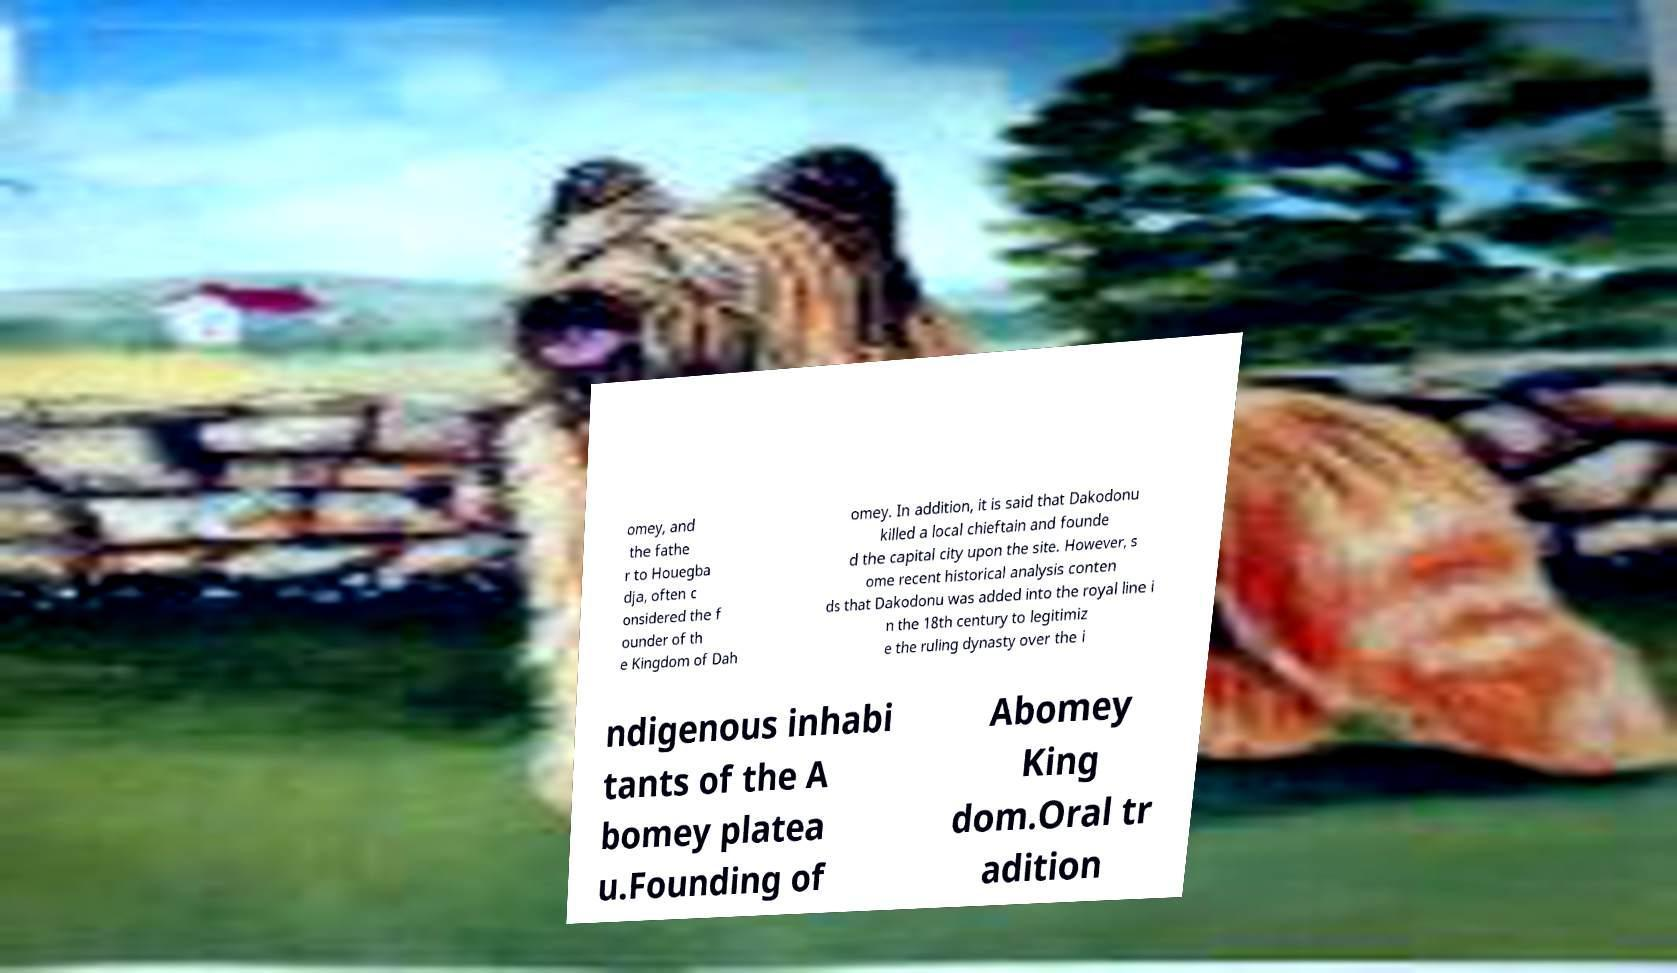Could you extract and type out the text from this image? omey, and the fathe r to Houegba dja, often c onsidered the f ounder of th e Kingdom of Dah omey. In addition, it is said that Dakodonu killed a local chieftain and founde d the capital city upon the site. However, s ome recent historical analysis conten ds that Dakodonu was added into the royal line i n the 18th century to legitimiz e the ruling dynasty over the i ndigenous inhabi tants of the A bomey platea u.Founding of Abomey King dom.Oral tr adition 